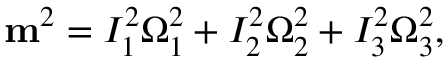<formula> <loc_0><loc_0><loc_500><loc_500>\begin{array} { r } { { m } ^ { 2 } = I _ { 1 } ^ { 2 } \Omega _ { 1 } ^ { 2 } + I _ { 2 } ^ { 2 } \Omega _ { 2 } ^ { 2 } + I _ { 3 } ^ { 2 } \Omega _ { 3 } ^ { 2 } , } \end{array}</formula> 